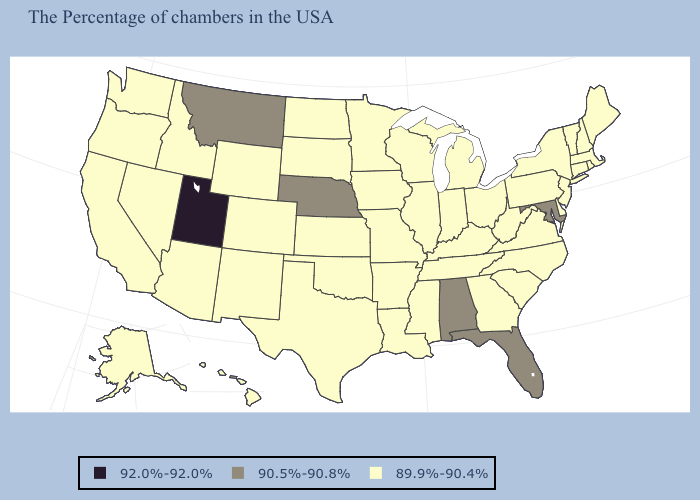Which states have the highest value in the USA?
Short answer required. Utah. What is the value of Wyoming?
Be succinct. 89.9%-90.4%. Which states hav the highest value in the West?
Give a very brief answer. Utah. Name the states that have a value in the range 92.0%-92.0%?
Answer briefly. Utah. What is the value of South Carolina?
Answer briefly. 89.9%-90.4%. What is the lowest value in the USA?
Write a very short answer. 89.9%-90.4%. Which states have the highest value in the USA?
Keep it brief. Utah. Name the states that have a value in the range 92.0%-92.0%?
Short answer required. Utah. What is the value of Maine?
Write a very short answer. 89.9%-90.4%. Which states have the lowest value in the Northeast?
Keep it brief. Maine, Massachusetts, Rhode Island, New Hampshire, Vermont, Connecticut, New York, New Jersey, Pennsylvania. What is the lowest value in the USA?
Give a very brief answer. 89.9%-90.4%. Name the states that have a value in the range 90.5%-90.8%?
Give a very brief answer. Maryland, Florida, Alabama, Nebraska, Montana. Does Maryland have the highest value in the South?
Concise answer only. Yes. What is the lowest value in the USA?
Quick response, please. 89.9%-90.4%. Among the states that border Michigan , which have the highest value?
Give a very brief answer. Ohio, Indiana, Wisconsin. 